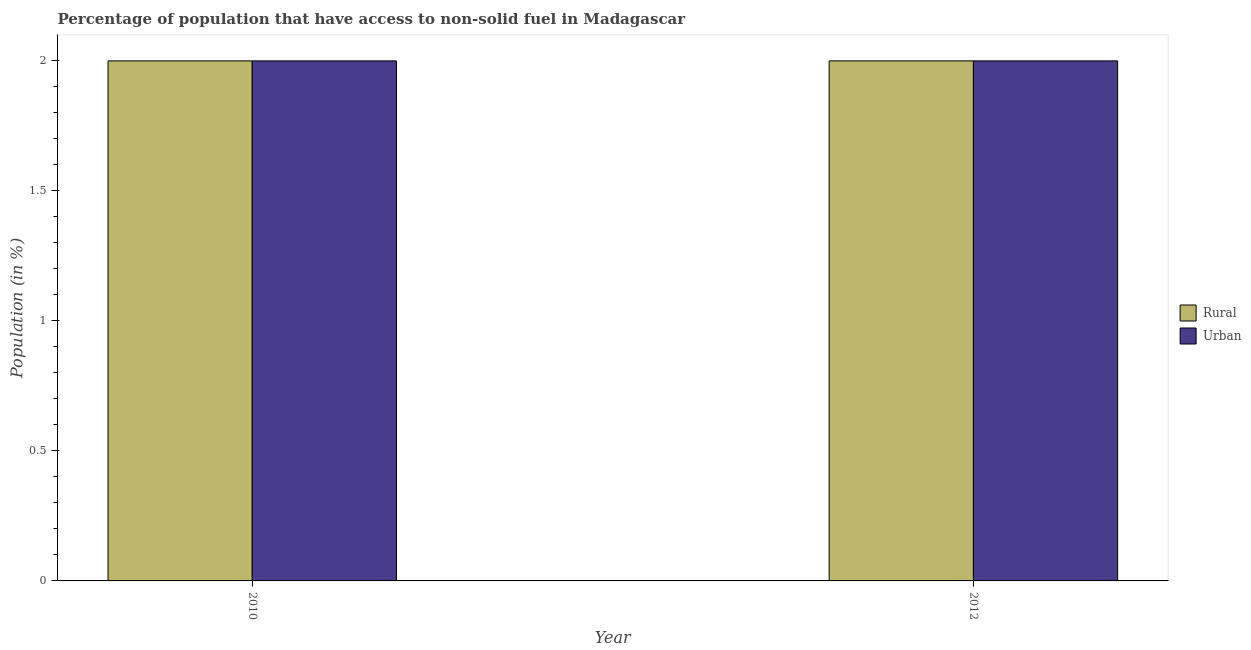Are the number of bars per tick equal to the number of legend labels?
Make the answer very short. Yes. How many bars are there on the 1st tick from the right?
Your response must be concise. 2. What is the urban population in 2012?
Give a very brief answer. 2. Across all years, what is the maximum rural population?
Provide a short and direct response. 2. Across all years, what is the minimum urban population?
Offer a very short reply. 2. In which year was the rural population maximum?
Your response must be concise. 2010. What is the total urban population in the graph?
Offer a terse response. 4. What is the difference between the rural population in 2012 and the urban population in 2010?
Your response must be concise. 0. What is the average urban population per year?
Your answer should be compact. 2. In how many years, is the rural population greater than 0.9 %?
Your answer should be very brief. 2. In how many years, is the urban population greater than the average urban population taken over all years?
Keep it short and to the point. 0. What does the 1st bar from the left in 2010 represents?
Your response must be concise. Rural. What does the 1st bar from the right in 2010 represents?
Your answer should be compact. Urban. How many bars are there?
Ensure brevity in your answer.  4. What is the difference between two consecutive major ticks on the Y-axis?
Give a very brief answer. 0.5. Does the graph contain any zero values?
Give a very brief answer. No. Where does the legend appear in the graph?
Your response must be concise. Center right. How are the legend labels stacked?
Your answer should be very brief. Vertical. What is the title of the graph?
Provide a succinct answer. Percentage of population that have access to non-solid fuel in Madagascar. Does "Age 65(female)" appear as one of the legend labels in the graph?
Give a very brief answer. No. What is the label or title of the Y-axis?
Make the answer very short. Population (in %). What is the Population (in %) of Rural in 2010?
Your answer should be very brief. 2. What is the Population (in %) in Urban in 2010?
Provide a short and direct response. 2. What is the Population (in %) of Rural in 2012?
Your answer should be compact. 2. What is the Population (in %) of Urban in 2012?
Provide a succinct answer. 2. Across all years, what is the maximum Population (in %) in Rural?
Provide a short and direct response. 2. Across all years, what is the maximum Population (in %) of Urban?
Offer a terse response. 2. Across all years, what is the minimum Population (in %) in Rural?
Provide a short and direct response. 2. Across all years, what is the minimum Population (in %) in Urban?
Provide a succinct answer. 2. What is the total Population (in %) in Rural in the graph?
Your response must be concise. 4. What is the difference between the Population (in %) in Urban in 2010 and that in 2012?
Provide a succinct answer. 0. What is the average Population (in %) of Rural per year?
Offer a very short reply. 2. What is the average Population (in %) of Urban per year?
Provide a short and direct response. 2. In the year 2012, what is the difference between the Population (in %) in Rural and Population (in %) in Urban?
Provide a short and direct response. 0. What is the ratio of the Population (in %) in Rural in 2010 to that in 2012?
Make the answer very short. 1. What is the ratio of the Population (in %) in Urban in 2010 to that in 2012?
Offer a terse response. 1. 